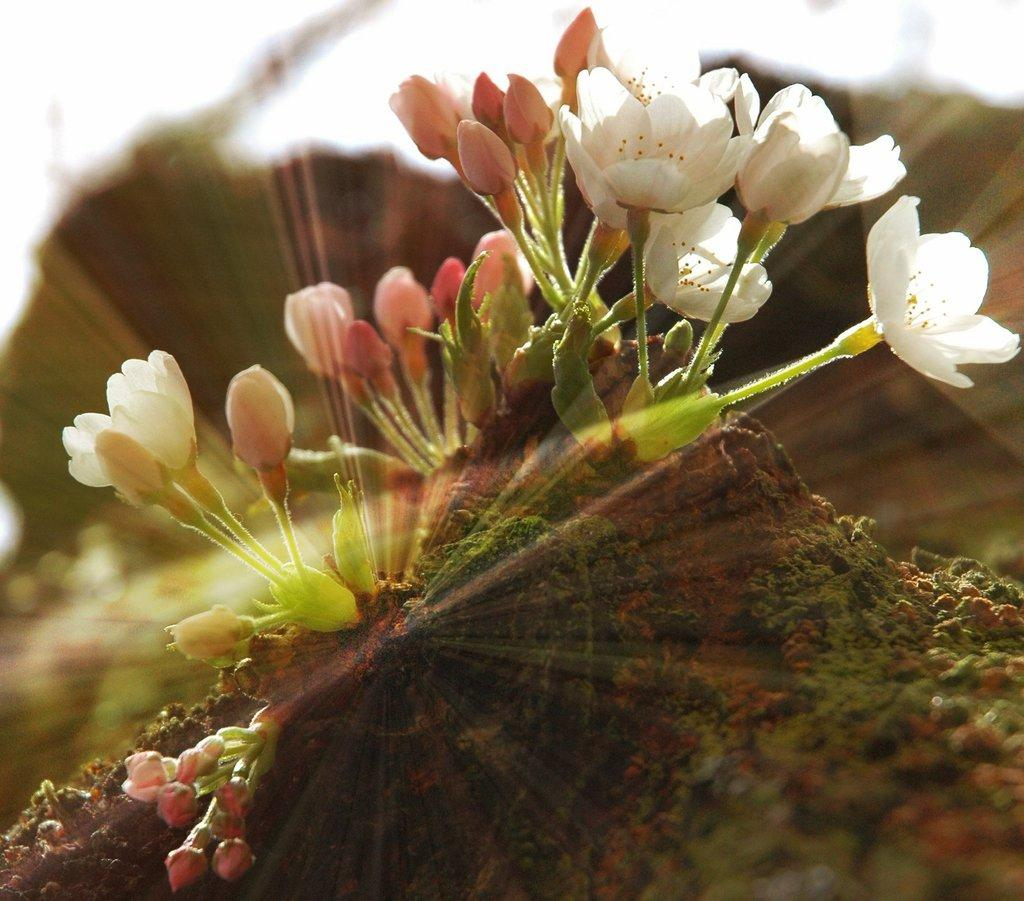What is on the ground in the image? There are flowers on the ground in the image. Can you describe the background of the image? The background of the image is blurry. What is the purpose of the tramp in the image? There is no tramp present in the image. Which company is responsible for the flowers in the image? The image does not provide information about the company responsible for the flowers. 